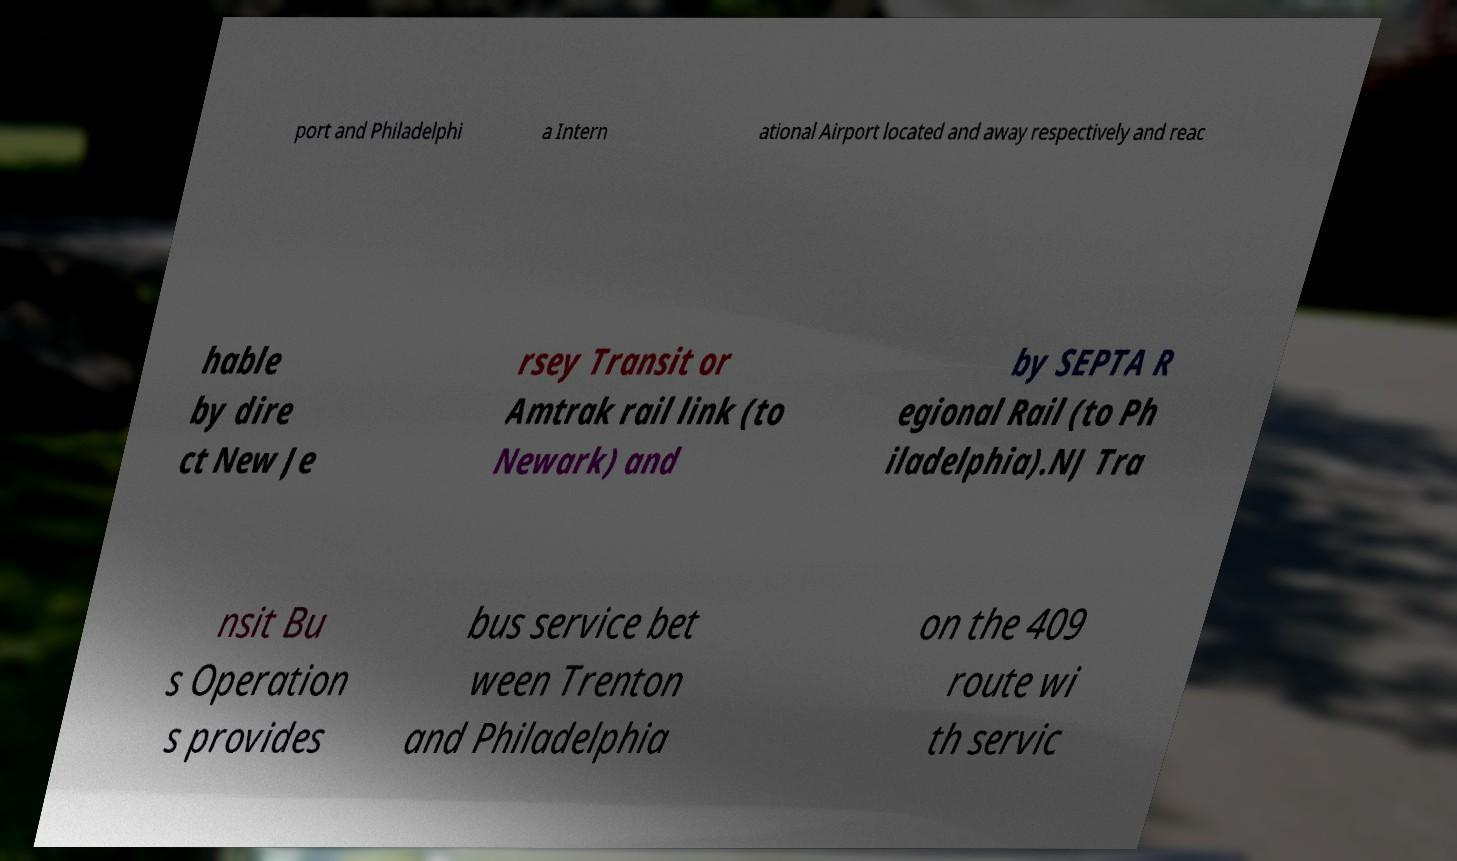There's text embedded in this image that I need extracted. Can you transcribe it verbatim? port and Philadelphi a Intern ational Airport located and away respectively and reac hable by dire ct New Je rsey Transit or Amtrak rail link (to Newark) and by SEPTA R egional Rail (to Ph iladelphia).NJ Tra nsit Bu s Operation s provides bus service bet ween Trenton and Philadelphia on the 409 route wi th servic 